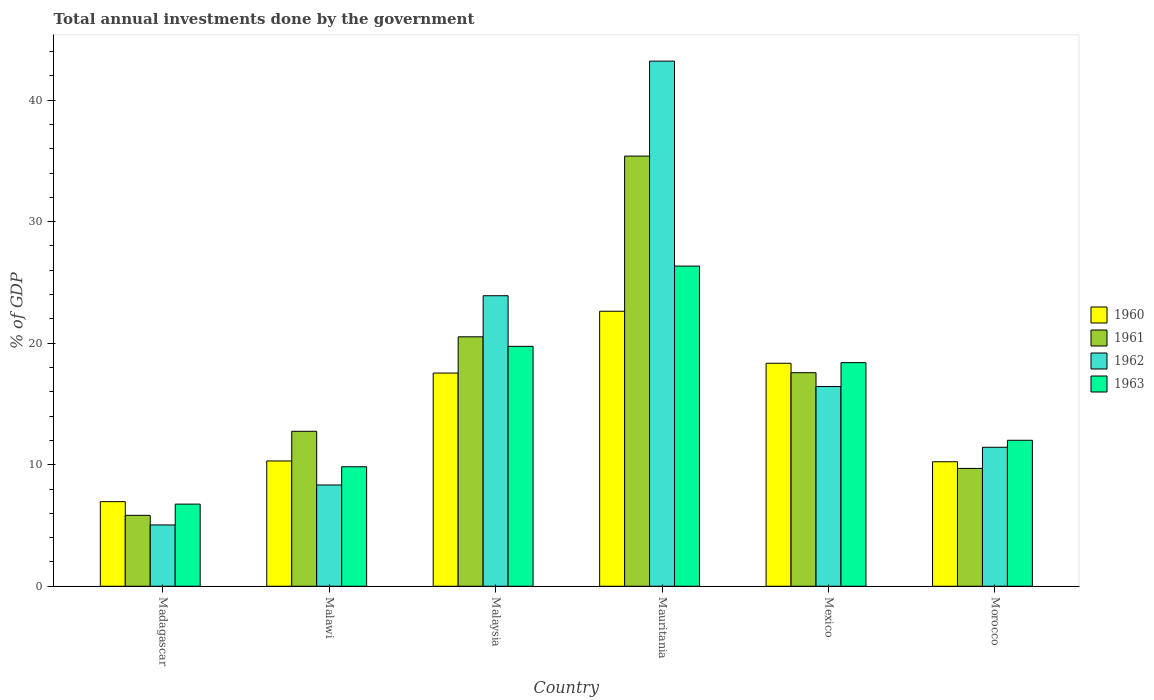How many different coloured bars are there?
Keep it short and to the point. 4. What is the label of the 4th group of bars from the left?
Give a very brief answer. Mauritania. What is the total annual investments done by the government in 1963 in Morocco?
Provide a succinct answer. 12.01. Across all countries, what is the maximum total annual investments done by the government in 1960?
Ensure brevity in your answer.  22.63. Across all countries, what is the minimum total annual investments done by the government in 1962?
Provide a succinct answer. 5.04. In which country was the total annual investments done by the government in 1961 maximum?
Ensure brevity in your answer.  Mauritania. In which country was the total annual investments done by the government in 1962 minimum?
Provide a succinct answer. Madagascar. What is the total total annual investments done by the government in 1960 in the graph?
Your answer should be compact. 86.03. What is the difference between the total annual investments done by the government in 1961 in Madagascar and that in Mauritania?
Offer a terse response. -29.56. What is the difference between the total annual investments done by the government in 1962 in Mexico and the total annual investments done by the government in 1963 in Madagascar?
Provide a succinct answer. 9.67. What is the average total annual investments done by the government in 1962 per country?
Offer a very short reply. 18.06. What is the difference between the total annual investments done by the government of/in 1961 and total annual investments done by the government of/in 1960 in Mauritania?
Offer a terse response. 12.77. What is the ratio of the total annual investments done by the government in 1961 in Mauritania to that in Morocco?
Provide a short and direct response. 3.65. Is the total annual investments done by the government in 1962 in Madagascar less than that in Malaysia?
Make the answer very short. Yes. What is the difference between the highest and the second highest total annual investments done by the government in 1962?
Offer a terse response. -26.77. What is the difference between the highest and the lowest total annual investments done by the government in 1960?
Provide a succinct answer. 15.67. Is the sum of the total annual investments done by the government in 1963 in Madagascar and Malaysia greater than the maximum total annual investments done by the government in 1961 across all countries?
Keep it short and to the point. No. How many countries are there in the graph?
Offer a terse response. 6. What is the difference between two consecutive major ticks on the Y-axis?
Give a very brief answer. 10. Are the values on the major ticks of Y-axis written in scientific E-notation?
Offer a very short reply. No. Does the graph contain any zero values?
Ensure brevity in your answer.  No. Does the graph contain grids?
Offer a very short reply. No. How many legend labels are there?
Your answer should be compact. 4. How are the legend labels stacked?
Your answer should be compact. Vertical. What is the title of the graph?
Make the answer very short. Total annual investments done by the government. Does "1996" appear as one of the legend labels in the graph?
Make the answer very short. No. What is the label or title of the Y-axis?
Give a very brief answer. % of GDP. What is the % of GDP of 1960 in Madagascar?
Offer a very short reply. 6.96. What is the % of GDP in 1961 in Madagascar?
Ensure brevity in your answer.  5.84. What is the % of GDP in 1962 in Madagascar?
Your answer should be compact. 5.04. What is the % of GDP in 1963 in Madagascar?
Make the answer very short. 6.76. What is the % of GDP in 1960 in Malawi?
Your answer should be compact. 10.31. What is the % of GDP in 1961 in Malawi?
Provide a succinct answer. 12.75. What is the % of GDP in 1962 in Malawi?
Your answer should be compact. 8.33. What is the % of GDP of 1963 in Malawi?
Your response must be concise. 9.83. What is the % of GDP of 1960 in Malaysia?
Your response must be concise. 17.54. What is the % of GDP of 1961 in Malaysia?
Your answer should be very brief. 20.52. What is the % of GDP of 1962 in Malaysia?
Offer a terse response. 23.9. What is the % of GDP of 1963 in Malaysia?
Give a very brief answer. 19.74. What is the % of GDP in 1960 in Mauritania?
Keep it short and to the point. 22.63. What is the % of GDP of 1961 in Mauritania?
Offer a terse response. 35.39. What is the % of GDP in 1962 in Mauritania?
Offer a terse response. 43.21. What is the % of GDP in 1963 in Mauritania?
Ensure brevity in your answer.  26.34. What is the % of GDP in 1960 in Mexico?
Give a very brief answer. 18.35. What is the % of GDP in 1961 in Mexico?
Give a very brief answer. 17.57. What is the % of GDP in 1962 in Mexico?
Provide a short and direct response. 16.43. What is the % of GDP of 1963 in Mexico?
Ensure brevity in your answer.  18.4. What is the % of GDP in 1960 in Morocco?
Provide a short and direct response. 10.24. What is the % of GDP in 1961 in Morocco?
Offer a terse response. 9.7. What is the % of GDP of 1962 in Morocco?
Provide a short and direct response. 11.43. What is the % of GDP of 1963 in Morocco?
Provide a short and direct response. 12.01. Across all countries, what is the maximum % of GDP in 1960?
Offer a very short reply. 22.63. Across all countries, what is the maximum % of GDP in 1961?
Provide a succinct answer. 35.39. Across all countries, what is the maximum % of GDP of 1962?
Ensure brevity in your answer.  43.21. Across all countries, what is the maximum % of GDP of 1963?
Give a very brief answer. 26.34. Across all countries, what is the minimum % of GDP of 1960?
Your answer should be very brief. 6.96. Across all countries, what is the minimum % of GDP in 1961?
Make the answer very short. 5.84. Across all countries, what is the minimum % of GDP of 1962?
Your answer should be very brief. 5.04. Across all countries, what is the minimum % of GDP in 1963?
Make the answer very short. 6.76. What is the total % of GDP of 1960 in the graph?
Ensure brevity in your answer.  86.03. What is the total % of GDP of 1961 in the graph?
Provide a short and direct response. 101.77. What is the total % of GDP of 1962 in the graph?
Offer a very short reply. 108.36. What is the total % of GDP of 1963 in the graph?
Keep it short and to the point. 93.08. What is the difference between the % of GDP in 1960 in Madagascar and that in Malawi?
Your response must be concise. -3.35. What is the difference between the % of GDP of 1961 in Madagascar and that in Malawi?
Keep it short and to the point. -6.92. What is the difference between the % of GDP in 1962 in Madagascar and that in Malawi?
Ensure brevity in your answer.  -3.29. What is the difference between the % of GDP in 1963 in Madagascar and that in Malawi?
Provide a succinct answer. -3.07. What is the difference between the % of GDP in 1960 in Madagascar and that in Malaysia?
Give a very brief answer. -10.58. What is the difference between the % of GDP in 1961 in Madagascar and that in Malaysia?
Ensure brevity in your answer.  -14.69. What is the difference between the % of GDP in 1962 in Madagascar and that in Malaysia?
Provide a short and direct response. -18.86. What is the difference between the % of GDP of 1963 in Madagascar and that in Malaysia?
Keep it short and to the point. -12.98. What is the difference between the % of GDP in 1960 in Madagascar and that in Mauritania?
Offer a terse response. -15.67. What is the difference between the % of GDP in 1961 in Madagascar and that in Mauritania?
Your answer should be very brief. -29.56. What is the difference between the % of GDP in 1962 in Madagascar and that in Mauritania?
Your response must be concise. -38.16. What is the difference between the % of GDP of 1963 in Madagascar and that in Mauritania?
Provide a succinct answer. -19.59. What is the difference between the % of GDP in 1960 in Madagascar and that in Mexico?
Keep it short and to the point. -11.38. What is the difference between the % of GDP of 1961 in Madagascar and that in Mexico?
Ensure brevity in your answer.  -11.74. What is the difference between the % of GDP in 1962 in Madagascar and that in Mexico?
Provide a short and direct response. -11.39. What is the difference between the % of GDP of 1963 in Madagascar and that in Mexico?
Your answer should be very brief. -11.64. What is the difference between the % of GDP of 1960 in Madagascar and that in Morocco?
Provide a succinct answer. -3.28. What is the difference between the % of GDP in 1961 in Madagascar and that in Morocco?
Give a very brief answer. -3.86. What is the difference between the % of GDP of 1962 in Madagascar and that in Morocco?
Offer a very short reply. -6.39. What is the difference between the % of GDP of 1963 in Madagascar and that in Morocco?
Ensure brevity in your answer.  -5.25. What is the difference between the % of GDP of 1960 in Malawi and that in Malaysia?
Your answer should be very brief. -7.23. What is the difference between the % of GDP in 1961 in Malawi and that in Malaysia?
Make the answer very short. -7.77. What is the difference between the % of GDP in 1962 in Malawi and that in Malaysia?
Give a very brief answer. -15.57. What is the difference between the % of GDP in 1963 in Malawi and that in Malaysia?
Your answer should be compact. -9.91. What is the difference between the % of GDP in 1960 in Malawi and that in Mauritania?
Your response must be concise. -12.32. What is the difference between the % of GDP in 1961 in Malawi and that in Mauritania?
Your response must be concise. -22.64. What is the difference between the % of GDP of 1962 in Malawi and that in Mauritania?
Your answer should be compact. -34.87. What is the difference between the % of GDP of 1963 in Malawi and that in Mauritania?
Provide a succinct answer. -16.51. What is the difference between the % of GDP of 1960 in Malawi and that in Mexico?
Your response must be concise. -8.04. What is the difference between the % of GDP of 1961 in Malawi and that in Mexico?
Give a very brief answer. -4.82. What is the difference between the % of GDP of 1962 in Malawi and that in Mexico?
Your response must be concise. -8.1. What is the difference between the % of GDP of 1963 in Malawi and that in Mexico?
Ensure brevity in your answer.  -8.57. What is the difference between the % of GDP of 1960 in Malawi and that in Morocco?
Your answer should be very brief. 0.07. What is the difference between the % of GDP of 1961 in Malawi and that in Morocco?
Make the answer very short. 3.06. What is the difference between the % of GDP of 1962 in Malawi and that in Morocco?
Give a very brief answer. -3.1. What is the difference between the % of GDP in 1963 in Malawi and that in Morocco?
Keep it short and to the point. -2.18. What is the difference between the % of GDP of 1960 in Malaysia and that in Mauritania?
Give a very brief answer. -5.09. What is the difference between the % of GDP of 1961 in Malaysia and that in Mauritania?
Make the answer very short. -14.87. What is the difference between the % of GDP of 1962 in Malaysia and that in Mauritania?
Provide a short and direct response. -19.3. What is the difference between the % of GDP in 1963 in Malaysia and that in Mauritania?
Ensure brevity in your answer.  -6.6. What is the difference between the % of GDP of 1960 in Malaysia and that in Mexico?
Provide a succinct answer. -0.8. What is the difference between the % of GDP in 1961 in Malaysia and that in Mexico?
Offer a terse response. 2.95. What is the difference between the % of GDP in 1962 in Malaysia and that in Mexico?
Provide a succinct answer. 7.47. What is the difference between the % of GDP in 1963 in Malaysia and that in Mexico?
Provide a short and direct response. 1.34. What is the difference between the % of GDP of 1960 in Malaysia and that in Morocco?
Make the answer very short. 7.3. What is the difference between the % of GDP of 1961 in Malaysia and that in Morocco?
Offer a terse response. 10.83. What is the difference between the % of GDP in 1962 in Malaysia and that in Morocco?
Provide a short and direct response. 12.47. What is the difference between the % of GDP of 1963 in Malaysia and that in Morocco?
Offer a terse response. 7.73. What is the difference between the % of GDP of 1960 in Mauritania and that in Mexico?
Ensure brevity in your answer.  4.28. What is the difference between the % of GDP of 1961 in Mauritania and that in Mexico?
Offer a very short reply. 17.82. What is the difference between the % of GDP in 1962 in Mauritania and that in Mexico?
Your answer should be compact. 26.77. What is the difference between the % of GDP of 1963 in Mauritania and that in Mexico?
Offer a very short reply. 7.94. What is the difference between the % of GDP of 1960 in Mauritania and that in Morocco?
Offer a very short reply. 12.38. What is the difference between the % of GDP of 1961 in Mauritania and that in Morocco?
Your answer should be compact. 25.7. What is the difference between the % of GDP of 1962 in Mauritania and that in Morocco?
Offer a very short reply. 31.77. What is the difference between the % of GDP in 1963 in Mauritania and that in Morocco?
Make the answer very short. 14.33. What is the difference between the % of GDP in 1960 in Mexico and that in Morocco?
Your response must be concise. 8.1. What is the difference between the % of GDP in 1961 in Mexico and that in Morocco?
Your response must be concise. 7.88. What is the difference between the % of GDP of 1962 in Mexico and that in Morocco?
Your answer should be compact. 5. What is the difference between the % of GDP of 1963 in Mexico and that in Morocco?
Make the answer very short. 6.39. What is the difference between the % of GDP in 1960 in Madagascar and the % of GDP in 1961 in Malawi?
Give a very brief answer. -5.79. What is the difference between the % of GDP of 1960 in Madagascar and the % of GDP of 1962 in Malawi?
Offer a terse response. -1.37. What is the difference between the % of GDP of 1960 in Madagascar and the % of GDP of 1963 in Malawi?
Keep it short and to the point. -2.87. What is the difference between the % of GDP of 1961 in Madagascar and the % of GDP of 1962 in Malawi?
Make the answer very short. -2.5. What is the difference between the % of GDP of 1961 in Madagascar and the % of GDP of 1963 in Malawi?
Give a very brief answer. -4. What is the difference between the % of GDP in 1962 in Madagascar and the % of GDP in 1963 in Malawi?
Offer a terse response. -4.79. What is the difference between the % of GDP in 1960 in Madagascar and the % of GDP in 1961 in Malaysia?
Make the answer very short. -13.56. What is the difference between the % of GDP of 1960 in Madagascar and the % of GDP of 1962 in Malaysia?
Make the answer very short. -16.94. What is the difference between the % of GDP of 1960 in Madagascar and the % of GDP of 1963 in Malaysia?
Your response must be concise. -12.78. What is the difference between the % of GDP of 1961 in Madagascar and the % of GDP of 1962 in Malaysia?
Provide a succinct answer. -18.07. What is the difference between the % of GDP of 1961 in Madagascar and the % of GDP of 1963 in Malaysia?
Make the answer very short. -13.9. What is the difference between the % of GDP of 1962 in Madagascar and the % of GDP of 1963 in Malaysia?
Keep it short and to the point. -14.7. What is the difference between the % of GDP of 1960 in Madagascar and the % of GDP of 1961 in Mauritania?
Ensure brevity in your answer.  -28.43. What is the difference between the % of GDP in 1960 in Madagascar and the % of GDP in 1962 in Mauritania?
Offer a terse response. -36.25. What is the difference between the % of GDP of 1960 in Madagascar and the % of GDP of 1963 in Mauritania?
Give a very brief answer. -19.38. What is the difference between the % of GDP in 1961 in Madagascar and the % of GDP in 1962 in Mauritania?
Make the answer very short. -37.37. What is the difference between the % of GDP in 1961 in Madagascar and the % of GDP in 1963 in Mauritania?
Provide a short and direct response. -20.51. What is the difference between the % of GDP in 1962 in Madagascar and the % of GDP in 1963 in Mauritania?
Make the answer very short. -21.3. What is the difference between the % of GDP in 1960 in Madagascar and the % of GDP in 1961 in Mexico?
Your answer should be compact. -10.61. What is the difference between the % of GDP in 1960 in Madagascar and the % of GDP in 1962 in Mexico?
Ensure brevity in your answer.  -9.47. What is the difference between the % of GDP in 1960 in Madagascar and the % of GDP in 1963 in Mexico?
Ensure brevity in your answer.  -11.44. What is the difference between the % of GDP of 1961 in Madagascar and the % of GDP of 1962 in Mexico?
Provide a succinct answer. -10.6. What is the difference between the % of GDP in 1961 in Madagascar and the % of GDP in 1963 in Mexico?
Your answer should be very brief. -12.56. What is the difference between the % of GDP in 1962 in Madagascar and the % of GDP in 1963 in Mexico?
Your answer should be very brief. -13.35. What is the difference between the % of GDP in 1960 in Madagascar and the % of GDP in 1961 in Morocco?
Offer a very short reply. -2.73. What is the difference between the % of GDP in 1960 in Madagascar and the % of GDP in 1962 in Morocco?
Provide a short and direct response. -4.47. What is the difference between the % of GDP of 1960 in Madagascar and the % of GDP of 1963 in Morocco?
Make the answer very short. -5.05. What is the difference between the % of GDP of 1961 in Madagascar and the % of GDP of 1962 in Morocco?
Give a very brief answer. -5.6. What is the difference between the % of GDP of 1961 in Madagascar and the % of GDP of 1963 in Morocco?
Offer a terse response. -6.17. What is the difference between the % of GDP of 1962 in Madagascar and the % of GDP of 1963 in Morocco?
Your response must be concise. -6.97. What is the difference between the % of GDP in 1960 in Malawi and the % of GDP in 1961 in Malaysia?
Your response must be concise. -10.22. What is the difference between the % of GDP of 1960 in Malawi and the % of GDP of 1962 in Malaysia?
Keep it short and to the point. -13.59. What is the difference between the % of GDP in 1960 in Malawi and the % of GDP in 1963 in Malaysia?
Provide a short and direct response. -9.43. What is the difference between the % of GDP in 1961 in Malawi and the % of GDP in 1962 in Malaysia?
Provide a succinct answer. -11.15. What is the difference between the % of GDP in 1961 in Malawi and the % of GDP in 1963 in Malaysia?
Your answer should be very brief. -6.99. What is the difference between the % of GDP in 1962 in Malawi and the % of GDP in 1963 in Malaysia?
Provide a short and direct response. -11.41. What is the difference between the % of GDP in 1960 in Malawi and the % of GDP in 1961 in Mauritania?
Offer a very short reply. -25.08. What is the difference between the % of GDP of 1960 in Malawi and the % of GDP of 1962 in Mauritania?
Provide a succinct answer. -32.9. What is the difference between the % of GDP in 1960 in Malawi and the % of GDP in 1963 in Mauritania?
Your response must be concise. -16.03. What is the difference between the % of GDP of 1961 in Malawi and the % of GDP of 1962 in Mauritania?
Provide a short and direct response. -30.46. What is the difference between the % of GDP of 1961 in Malawi and the % of GDP of 1963 in Mauritania?
Your answer should be compact. -13.59. What is the difference between the % of GDP in 1962 in Malawi and the % of GDP in 1963 in Mauritania?
Give a very brief answer. -18.01. What is the difference between the % of GDP in 1960 in Malawi and the % of GDP in 1961 in Mexico?
Your response must be concise. -7.26. What is the difference between the % of GDP in 1960 in Malawi and the % of GDP in 1962 in Mexico?
Make the answer very short. -6.12. What is the difference between the % of GDP in 1960 in Malawi and the % of GDP in 1963 in Mexico?
Your answer should be very brief. -8.09. What is the difference between the % of GDP of 1961 in Malawi and the % of GDP of 1962 in Mexico?
Keep it short and to the point. -3.68. What is the difference between the % of GDP of 1961 in Malawi and the % of GDP of 1963 in Mexico?
Provide a succinct answer. -5.65. What is the difference between the % of GDP of 1962 in Malawi and the % of GDP of 1963 in Mexico?
Your answer should be compact. -10.07. What is the difference between the % of GDP of 1960 in Malawi and the % of GDP of 1961 in Morocco?
Your response must be concise. 0.61. What is the difference between the % of GDP in 1960 in Malawi and the % of GDP in 1962 in Morocco?
Offer a terse response. -1.13. What is the difference between the % of GDP of 1960 in Malawi and the % of GDP of 1963 in Morocco?
Make the answer very short. -1.7. What is the difference between the % of GDP of 1961 in Malawi and the % of GDP of 1962 in Morocco?
Offer a very short reply. 1.32. What is the difference between the % of GDP in 1961 in Malawi and the % of GDP in 1963 in Morocco?
Offer a terse response. 0.74. What is the difference between the % of GDP in 1962 in Malawi and the % of GDP in 1963 in Morocco?
Make the answer very short. -3.68. What is the difference between the % of GDP in 1960 in Malaysia and the % of GDP in 1961 in Mauritania?
Ensure brevity in your answer.  -17.85. What is the difference between the % of GDP of 1960 in Malaysia and the % of GDP of 1962 in Mauritania?
Your response must be concise. -25.67. What is the difference between the % of GDP in 1960 in Malaysia and the % of GDP in 1963 in Mauritania?
Your answer should be compact. -8.8. What is the difference between the % of GDP in 1961 in Malaysia and the % of GDP in 1962 in Mauritania?
Offer a very short reply. -22.68. What is the difference between the % of GDP in 1961 in Malaysia and the % of GDP in 1963 in Mauritania?
Offer a terse response. -5.82. What is the difference between the % of GDP in 1962 in Malaysia and the % of GDP in 1963 in Mauritania?
Provide a short and direct response. -2.44. What is the difference between the % of GDP in 1960 in Malaysia and the % of GDP in 1961 in Mexico?
Provide a succinct answer. -0.03. What is the difference between the % of GDP in 1960 in Malaysia and the % of GDP in 1962 in Mexico?
Keep it short and to the point. 1.11. What is the difference between the % of GDP in 1960 in Malaysia and the % of GDP in 1963 in Mexico?
Provide a short and direct response. -0.86. What is the difference between the % of GDP of 1961 in Malaysia and the % of GDP of 1962 in Mexico?
Your answer should be compact. 4.09. What is the difference between the % of GDP in 1961 in Malaysia and the % of GDP in 1963 in Mexico?
Provide a short and direct response. 2.13. What is the difference between the % of GDP of 1962 in Malaysia and the % of GDP of 1963 in Mexico?
Your answer should be compact. 5.5. What is the difference between the % of GDP of 1960 in Malaysia and the % of GDP of 1961 in Morocco?
Offer a very short reply. 7.85. What is the difference between the % of GDP in 1960 in Malaysia and the % of GDP in 1962 in Morocco?
Ensure brevity in your answer.  6.11. What is the difference between the % of GDP in 1960 in Malaysia and the % of GDP in 1963 in Morocco?
Provide a succinct answer. 5.53. What is the difference between the % of GDP in 1961 in Malaysia and the % of GDP in 1962 in Morocco?
Your answer should be compact. 9.09. What is the difference between the % of GDP of 1961 in Malaysia and the % of GDP of 1963 in Morocco?
Offer a very short reply. 8.51. What is the difference between the % of GDP of 1962 in Malaysia and the % of GDP of 1963 in Morocco?
Offer a terse response. 11.89. What is the difference between the % of GDP in 1960 in Mauritania and the % of GDP in 1961 in Mexico?
Keep it short and to the point. 5.06. What is the difference between the % of GDP in 1960 in Mauritania and the % of GDP in 1962 in Mexico?
Your answer should be compact. 6.2. What is the difference between the % of GDP of 1960 in Mauritania and the % of GDP of 1963 in Mexico?
Give a very brief answer. 4.23. What is the difference between the % of GDP of 1961 in Mauritania and the % of GDP of 1962 in Mexico?
Your answer should be compact. 18.96. What is the difference between the % of GDP in 1961 in Mauritania and the % of GDP in 1963 in Mexico?
Make the answer very short. 16.99. What is the difference between the % of GDP in 1962 in Mauritania and the % of GDP in 1963 in Mexico?
Your response must be concise. 24.81. What is the difference between the % of GDP in 1960 in Mauritania and the % of GDP in 1961 in Morocco?
Give a very brief answer. 12.93. What is the difference between the % of GDP of 1960 in Mauritania and the % of GDP of 1962 in Morocco?
Provide a succinct answer. 11.19. What is the difference between the % of GDP in 1960 in Mauritania and the % of GDP in 1963 in Morocco?
Offer a terse response. 10.62. What is the difference between the % of GDP in 1961 in Mauritania and the % of GDP in 1962 in Morocco?
Provide a short and direct response. 23.96. What is the difference between the % of GDP in 1961 in Mauritania and the % of GDP in 1963 in Morocco?
Make the answer very short. 23.38. What is the difference between the % of GDP of 1962 in Mauritania and the % of GDP of 1963 in Morocco?
Keep it short and to the point. 31.2. What is the difference between the % of GDP in 1960 in Mexico and the % of GDP in 1961 in Morocco?
Give a very brief answer. 8.65. What is the difference between the % of GDP in 1960 in Mexico and the % of GDP in 1962 in Morocco?
Provide a short and direct response. 6.91. What is the difference between the % of GDP of 1960 in Mexico and the % of GDP of 1963 in Morocco?
Your answer should be compact. 6.34. What is the difference between the % of GDP in 1961 in Mexico and the % of GDP in 1962 in Morocco?
Offer a very short reply. 6.14. What is the difference between the % of GDP of 1961 in Mexico and the % of GDP of 1963 in Morocco?
Provide a succinct answer. 5.56. What is the difference between the % of GDP of 1962 in Mexico and the % of GDP of 1963 in Morocco?
Ensure brevity in your answer.  4.42. What is the average % of GDP of 1960 per country?
Offer a terse response. 14.34. What is the average % of GDP of 1961 per country?
Offer a terse response. 16.96. What is the average % of GDP of 1962 per country?
Offer a very short reply. 18.06. What is the average % of GDP in 1963 per country?
Offer a very short reply. 15.51. What is the difference between the % of GDP of 1960 and % of GDP of 1961 in Madagascar?
Offer a very short reply. 1.13. What is the difference between the % of GDP of 1960 and % of GDP of 1962 in Madagascar?
Your response must be concise. 1.92. What is the difference between the % of GDP of 1960 and % of GDP of 1963 in Madagascar?
Offer a very short reply. 0.2. What is the difference between the % of GDP of 1961 and % of GDP of 1962 in Madagascar?
Your answer should be compact. 0.79. What is the difference between the % of GDP in 1961 and % of GDP in 1963 in Madagascar?
Provide a short and direct response. -0.92. What is the difference between the % of GDP of 1962 and % of GDP of 1963 in Madagascar?
Keep it short and to the point. -1.71. What is the difference between the % of GDP in 1960 and % of GDP in 1961 in Malawi?
Your response must be concise. -2.44. What is the difference between the % of GDP in 1960 and % of GDP in 1962 in Malawi?
Provide a short and direct response. 1.98. What is the difference between the % of GDP in 1960 and % of GDP in 1963 in Malawi?
Provide a succinct answer. 0.48. What is the difference between the % of GDP of 1961 and % of GDP of 1962 in Malawi?
Your answer should be very brief. 4.42. What is the difference between the % of GDP in 1961 and % of GDP in 1963 in Malawi?
Your response must be concise. 2.92. What is the difference between the % of GDP in 1962 and % of GDP in 1963 in Malawi?
Keep it short and to the point. -1.5. What is the difference between the % of GDP of 1960 and % of GDP of 1961 in Malaysia?
Provide a short and direct response. -2.98. What is the difference between the % of GDP of 1960 and % of GDP of 1962 in Malaysia?
Your response must be concise. -6.36. What is the difference between the % of GDP in 1960 and % of GDP in 1963 in Malaysia?
Offer a very short reply. -2.2. What is the difference between the % of GDP of 1961 and % of GDP of 1962 in Malaysia?
Your answer should be very brief. -3.38. What is the difference between the % of GDP in 1961 and % of GDP in 1963 in Malaysia?
Your answer should be compact. 0.78. What is the difference between the % of GDP of 1962 and % of GDP of 1963 in Malaysia?
Make the answer very short. 4.16. What is the difference between the % of GDP in 1960 and % of GDP in 1961 in Mauritania?
Provide a short and direct response. -12.77. What is the difference between the % of GDP of 1960 and % of GDP of 1962 in Mauritania?
Make the answer very short. -20.58. What is the difference between the % of GDP of 1960 and % of GDP of 1963 in Mauritania?
Offer a very short reply. -3.72. What is the difference between the % of GDP in 1961 and % of GDP in 1962 in Mauritania?
Your answer should be compact. -7.81. What is the difference between the % of GDP in 1961 and % of GDP in 1963 in Mauritania?
Your answer should be very brief. 9.05. What is the difference between the % of GDP of 1962 and % of GDP of 1963 in Mauritania?
Offer a very short reply. 16.86. What is the difference between the % of GDP of 1960 and % of GDP of 1961 in Mexico?
Your answer should be compact. 0.77. What is the difference between the % of GDP in 1960 and % of GDP in 1962 in Mexico?
Your answer should be very brief. 1.91. What is the difference between the % of GDP in 1960 and % of GDP in 1963 in Mexico?
Provide a succinct answer. -0.05. What is the difference between the % of GDP in 1961 and % of GDP in 1962 in Mexico?
Offer a terse response. 1.14. What is the difference between the % of GDP of 1961 and % of GDP of 1963 in Mexico?
Your answer should be compact. -0.83. What is the difference between the % of GDP of 1962 and % of GDP of 1963 in Mexico?
Your answer should be compact. -1.97. What is the difference between the % of GDP in 1960 and % of GDP in 1961 in Morocco?
Offer a terse response. 0.55. What is the difference between the % of GDP of 1960 and % of GDP of 1962 in Morocco?
Ensure brevity in your answer.  -1.19. What is the difference between the % of GDP of 1960 and % of GDP of 1963 in Morocco?
Provide a succinct answer. -1.77. What is the difference between the % of GDP of 1961 and % of GDP of 1962 in Morocco?
Your response must be concise. -1.74. What is the difference between the % of GDP of 1961 and % of GDP of 1963 in Morocco?
Make the answer very short. -2.32. What is the difference between the % of GDP of 1962 and % of GDP of 1963 in Morocco?
Offer a terse response. -0.58. What is the ratio of the % of GDP in 1960 in Madagascar to that in Malawi?
Your answer should be compact. 0.68. What is the ratio of the % of GDP in 1961 in Madagascar to that in Malawi?
Offer a terse response. 0.46. What is the ratio of the % of GDP of 1962 in Madagascar to that in Malawi?
Your answer should be very brief. 0.61. What is the ratio of the % of GDP of 1963 in Madagascar to that in Malawi?
Offer a very short reply. 0.69. What is the ratio of the % of GDP of 1960 in Madagascar to that in Malaysia?
Provide a short and direct response. 0.4. What is the ratio of the % of GDP of 1961 in Madagascar to that in Malaysia?
Provide a short and direct response. 0.28. What is the ratio of the % of GDP of 1962 in Madagascar to that in Malaysia?
Offer a terse response. 0.21. What is the ratio of the % of GDP in 1963 in Madagascar to that in Malaysia?
Ensure brevity in your answer.  0.34. What is the ratio of the % of GDP in 1960 in Madagascar to that in Mauritania?
Provide a short and direct response. 0.31. What is the ratio of the % of GDP of 1961 in Madagascar to that in Mauritania?
Your response must be concise. 0.16. What is the ratio of the % of GDP in 1962 in Madagascar to that in Mauritania?
Your answer should be compact. 0.12. What is the ratio of the % of GDP of 1963 in Madagascar to that in Mauritania?
Give a very brief answer. 0.26. What is the ratio of the % of GDP in 1960 in Madagascar to that in Mexico?
Offer a terse response. 0.38. What is the ratio of the % of GDP of 1961 in Madagascar to that in Mexico?
Ensure brevity in your answer.  0.33. What is the ratio of the % of GDP in 1962 in Madagascar to that in Mexico?
Make the answer very short. 0.31. What is the ratio of the % of GDP of 1963 in Madagascar to that in Mexico?
Ensure brevity in your answer.  0.37. What is the ratio of the % of GDP of 1960 in Madagascar to that in Morocco?
Provide a short and direct response. 0.68. What is the ratio of the % of GDP in 1961 in Madagascar to that in Morocco?
Ensure brevity in your answer.  0.6. What is the ratio of the % of GDP of 1962 in Madagascar to that in Morocco?
Give a very brief answer. 0.44. What is the ratio of the % of GDP in 1963 in Madagascar to that in Morocco?
Provide a succinct answer. 0.56. What is the ratio of the % of GDP of 1960 in Malawi to that in Malaysia?
Your answer should be compact. 0.59. What is the ratio of the % of GDP of 1961 in Malawi to that in Malaysia?
Your answer should be very brief. 0.62. What is the ratio of the % of GDP in 1962 in Malawi to that in Malaysia?
Your response must be concise. 0.35. What is the ratio of the % of GDP of 1963 in Malawi to that in Malaysia?
Provide a short and direct response. 0.5. What is the ratio of the % of GDP of 1960 in Malawi to that in Mauritania?
Offer a very short reply. 0.46. What is the ratio of the % of GDP in 1961 in Malawi to that in Mauritania?
Offer a terse response. 0.36. What is the ratio of the % of GDP of 1962 in Malawi to that in Mauritania?
Offer a very short reply. 0.19. What is the ratio of the % of GDP in 1963 in Malawi to that in Mauritania?
Provide a succinct answer. 0.37. What is the ratio of the % of GDP in 1960 in Malawi to that in Mexico?
Your answer should be compact. 0.56. What is the ratio of the % of GDP in 1961 in Malawi to that in Mexico?
Offer a terse response. 0.73. What is the ratio of the % of GDP of 1962 in Malawi to that in Mexico?
Provide a succinct answer. 0.51. What is the ratio of the % of GDP in 1963 in Malawi to that in Mexico?
Give a very brief answer. 0.53. What is the ratio of the % of GDP of 1960 in Malawi to that in Morocco?
Your answer should be compact. 1.01. What is the ratio of the % of GDP in 1961 in Malawi to that in Morocco?
Your answer should be compact. 1.32. What is the ratio of the % of GDP in 1962 in Malawi to that in Morocco?
Keep it short and to the point. 0.73. What is the ratio of the % of GDP of 1963 in Malawi to that in Morocco?
Offer a very short reply. 0.82. What is the ratio of the % of GDP of 1960 in Malaysia to that in Mauritania?
Offer a very short reply. 0.78. What is the ratio of the % of GDP in 1961 in Malaysia to that in Mauritania?
Offer a terse response. 0.58. What is the ratio of the % of GDP of 1962 in Malaysia to that in Mauritania?
Keep it short and to the point. 0.55. What is the ratio of the % of GDP in 1963 in Malaysia to that in Mauritania?
Your answer should be very brief. 0.75. What is the ratio of the % of GDP of 1960 in Malaysia to that in Mexico?
Offer a very short reply. 0.96. What is the ratio of the % of GDP of 1961 in Malaysia to that in Mexico?
Provide a succinct answer. 1.17. What is the ratio of the % of GDP in 1962 in Malaysia to that in Mexico?
Provide a short and direct response. 1.45. What is the ratio of the % of GDP in 1963 in Malaysia to that in Mexico?
Give a very brief answer. 1.07. What is the ratio of the % of GDP of 1960 in Malaysia to that in Morocco?
Give a very brief answer. 1.71. What is the ratio of the % of GDP of 1961 in Malaysia to that in Morocco?
Keep it short and to the point. 2.12. What is the ratio of the % of GDP in 1962 in Malaysia to that in Morocco?
Offer a very short reply. 2.09. What is the ratio of the % of GDP in 1963 in Malaysia to that in Morocco?
Give a very brief answer. 1.64. What is the ratio of the % of GDP in 1960 in Mauritania to that in Mexico?
Offer a terse response. 1.23. What is the ratio of the % of GDP of 1961 in Mauritania to that in Mexico?
Offer a very short reply. 2.01. What is the ratio of the % of GDP in 1962 in Mauritania to that in Mexico?
Offer a very short reply. 2.63. What is the ratio of the % of GDP in 1963 in Mauritania to that in Mexico?
Your answer should be very brief. 1.43. What is the ratio of the % of GDP in 1960 in Mauritania to that in Morocco?
Give a very brief answer. 2.21. What is the ratio of the % of GDP of 1961 in Mauritania to that in Morocco?
Offer a terse response. 3.65. What is the ratio of the % of GDP of 1962 in Mauritania to that in Morocco?
Offer a terse response. 3.78. What is the ratio of the % of GDP in 1963 in Mauritania to that in Morocco?
Ensure brevity in your answer.  2.19. What is the ratio of the % of GDP of 1960 in Mexico to that in Morocco?
Keep it short and to the point. 1.79. What is the ratio of the % of GDP of 1961 in Mexico to that in Morocco?
Your response must be concise. 1.81. What is the ratio of the % of GDP in 1962 in Mexico to that in Morocco?
Keep it short and to the point. 1.44. What is the ratio of the % of GDP in 1963 in Mexico to that in Morocco?
Provide a succinct answer. 1.53. What is the difference between the highest and the second highest % of GDP of 1960?
Your answer should be compact. 4.28. What is the difference between the highest and the second highest % of GDP of 1961?
Keep it short and to the point. 14.87. What is the difference between the highest and the second highest % of GDP in 1962?
Provide a succinct answer. 19.3. What is the difference between the highest and the second highest % of GDP of 1963?
Your answer should be compact. 6.6. What is the difference between the highest and the lowest % of GDP in 1960?
Give a very brief answer. 15.67. What is the difference between the highest and the lowest % of GDP in 1961?
Your answer should be very brief. 29.56. What is the difference between the highest and the lowest % of GDP of 1962?
Your response must be concise. 38.16. What is the difference between the highest and the lowest % of GDP of 1963?
Your answer should be very brief. 19.59. 